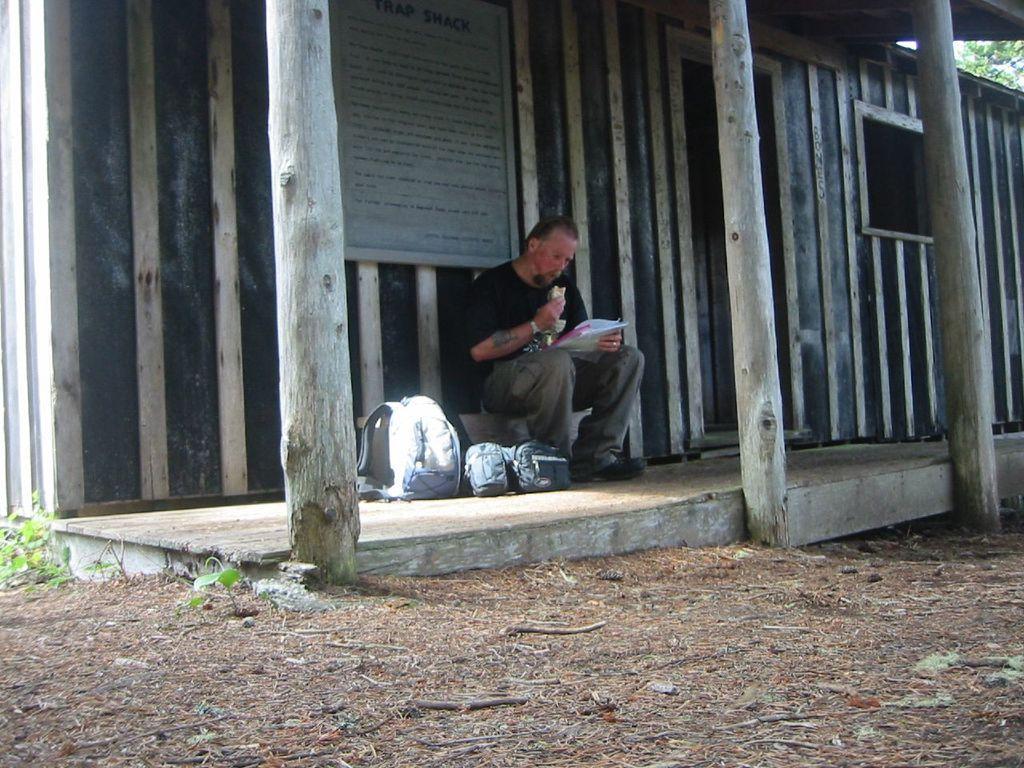In one or two sentences, can you explain what this image depicts? In this image there is a person sitting and holding an object, there are bags on the ground, there are plants, there is a plant truncated towards the left of the image, there is a wall truncated, there is a board on the wall, there is text on the board, there are wooden poles truncated towards the top of the image, there is a roof truncated towards the top of the image, there are wooden poles truncated towards the top of the image, there is a tree truncated towards the right of the image. 